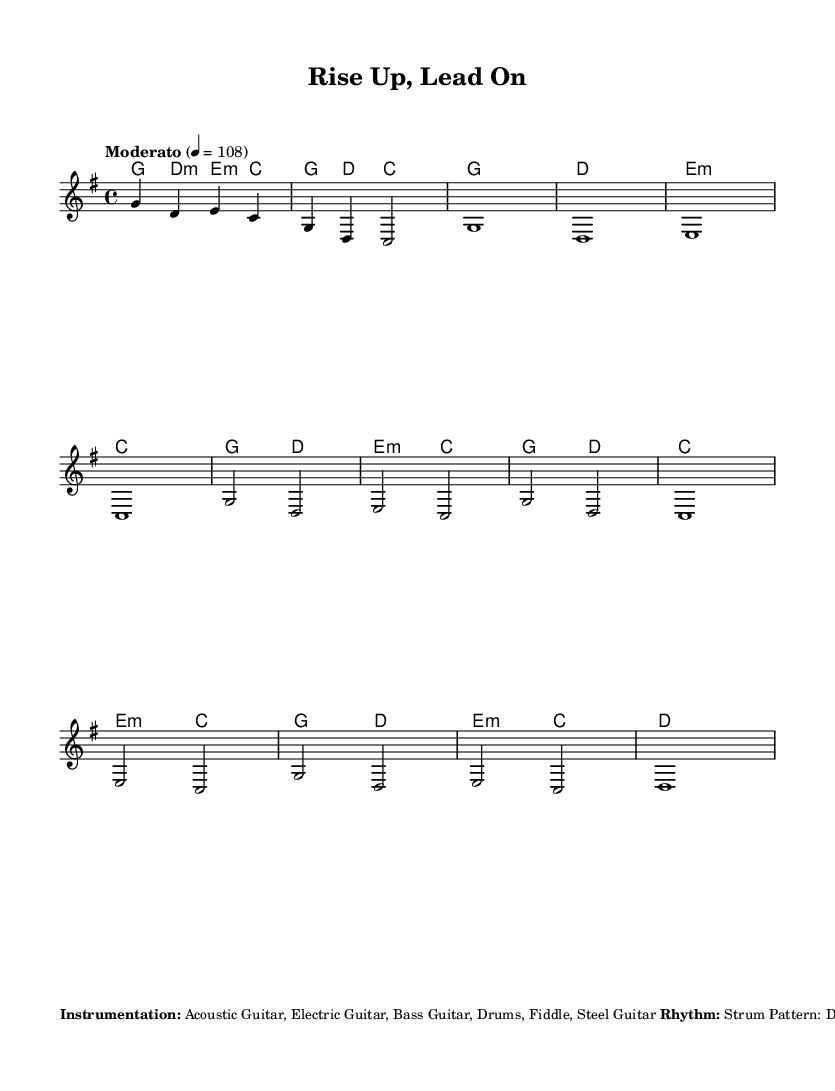What is the key signature of this music? The key signature is G major, which indicates one sharp (F#). This is determined by looking at the `\key g \major` line in the code.
Answer: G major What is the time signature of this piece? The time signature is 4/4, which is evident from the `\time 4/4` line in the score. This means there are four beats in each measure.
Answer: 4/4 What is the tempo indicated in the music? The tempo marking is "Moderato" with a note value indicating the speed of 108 beats per minute, shown by the line `\tempo "Moderato" 4 = 108`.
Answer: Moderato 108 How many measures are in the chorus section? The chorus has four measures based on the notation provided in the `melody` section where the chorus is defined. Each line corresponds to a measure, making it four.
Answer: 4 What instruments are specified for this arrangement? The instruments listed are Acoustic Guitar, Electric Guitar, Bass Guitar, Drums, Fiddle, and Steel Guitar as found in the `\markup` section.
Answer: Acoustic Guitar, Electric Guitar, Bass Guitar, Drums, Fiddle, Steel Guitar What type of strum pattern is indicated in the sheet music? The strum pattern is specified as D DU UDU, noted in the `\markup` section under "Rhythm". "D" stands for downstroke, and "U" for upstroke in strumming style.
Answer: D DU UDU 